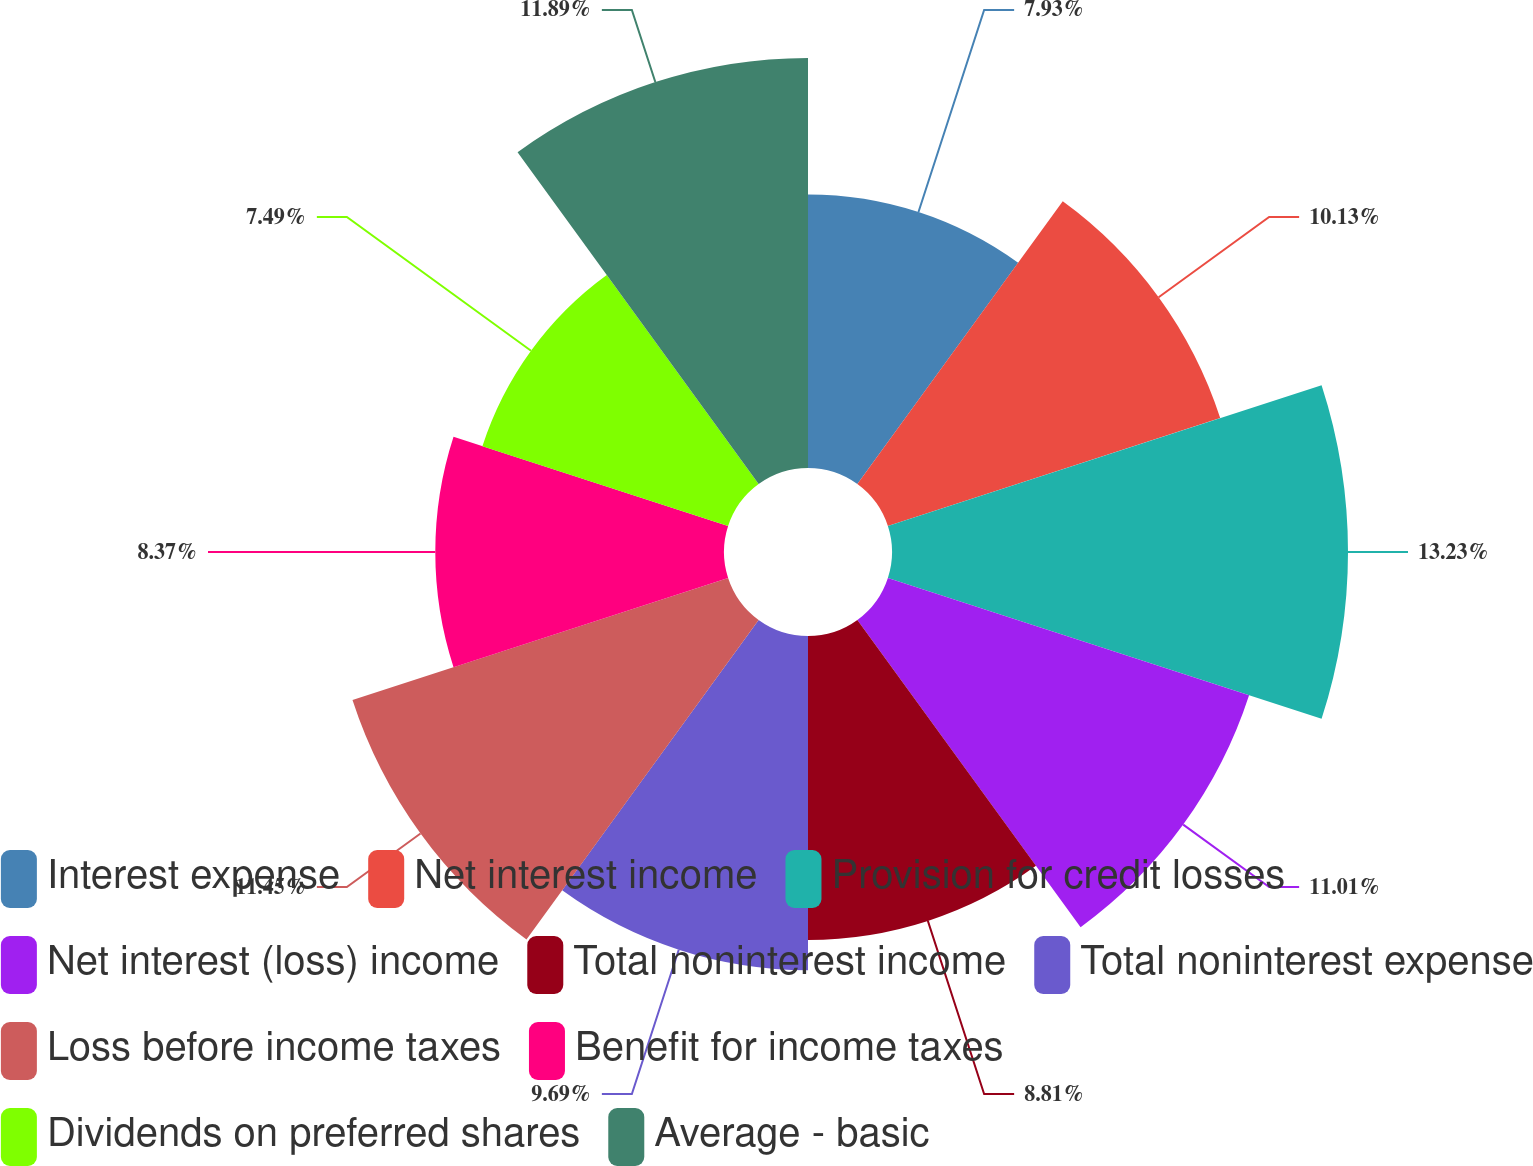<chart> <loc_0><loc_0><loc_500><loc_500><pie_chart><fcel>Interest expense<fcel>Net interest income<fcel>Provision for credit losses<fcel>Net interest (loss) income<fcel>Total noninterest income<fcel>Total noninterest expense<fcel>Loss before income taxes<fcel>Benefit for income taxes<fcel>Dividends on preferred shares<fcel>Average - basic<nl><fcel>7.93%<fcel>10.13%<fcel>13.22%<fcel>11.01%<fcel>8.81%<fcel>9.69%<fcel>11.45%<fcel>8.37%<fcel>7.49%<fcel>11.89%<nl></chart> 